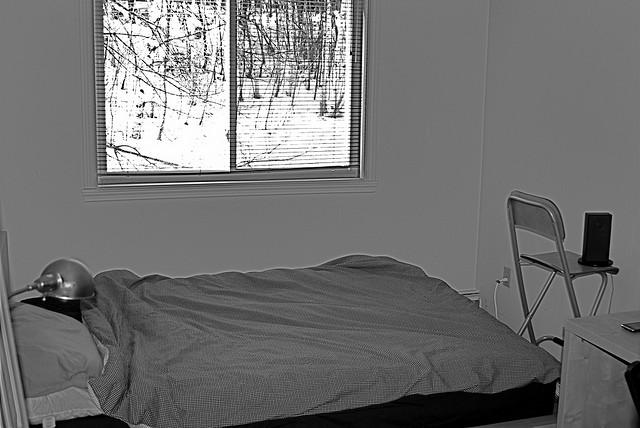Do the windows raise?
Keep it brief. No. Is the bed made?
Give a very brief answer. No. What window covering is in this room?
Write a very short answer. Blinds. What is in the backyard?
Give a very brief answer. Snow. Is it a warm day?
Write a very short answer. No. What shapes are patterned on the bedspread?
Answer briefly. None. Is it likely to snow today?
Concise answer only. Yes. What is in the window?
Answer briefly. Trees. Is there snow outside?
Concise answer only. Yes. Is there a speaker in the room?
Be succinct. Yes. Is anyone sleeping in this photo?
Answer briefly. No. Is that bed comfortable?
Be succinct. Yes. 